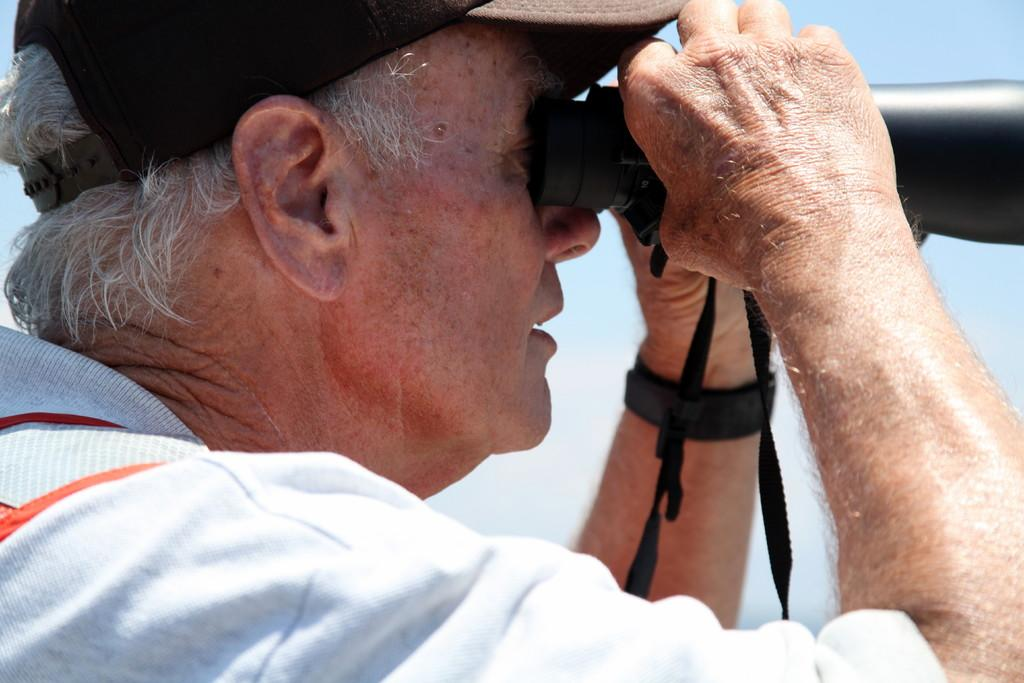What is the main subject in the foreground of the picture? There is a man in the foreground of the picture. What is the man wearing? The man is wearing a white T-shirt. What object is the man holding in his hand? The man is holding a binoculars telescope in his hand. What can be seen in the background of the picture? There is a sky visible in the background of the picture. Is there a hydrant visible in the picture? There is no hydrant present in the image. What type of light can be seen coming from the volcano in the picture? There is no volcano present in the image, so no light can be seen coming from it. 